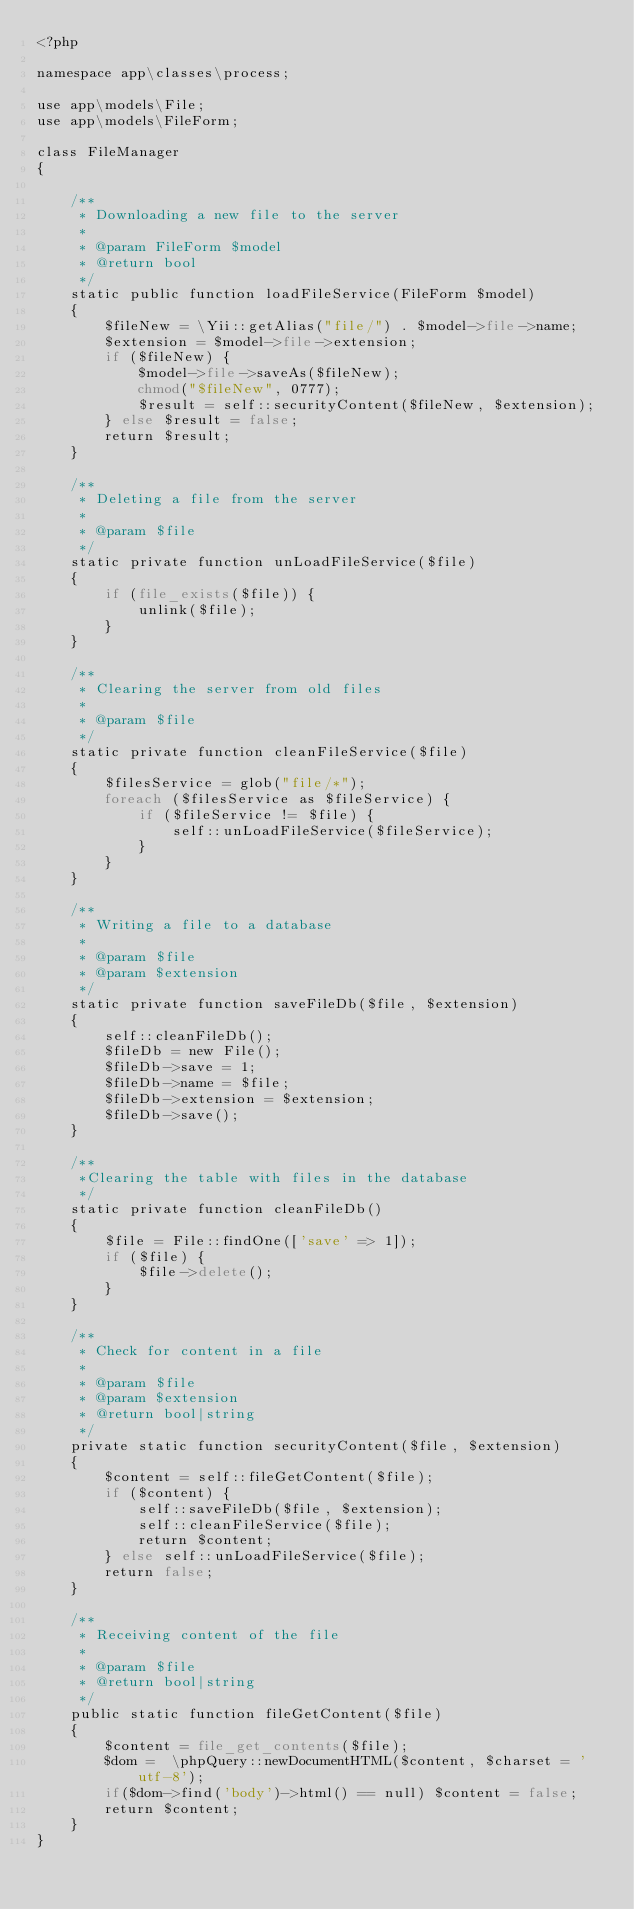Convert code to text. <code><loc_0><loc_0><loc_500><loc_500><_PHP_><?php

namespace app\classes\process;

use app\models\File;
use app\models\FileForm;

class FileManager
{

    /**
     * Downloading a new file to the server
     *
     * @param FileForm $model
     * @return bool
     */
    static public function loadFileService(FileForm $model)
    {
        $fileNew = \Yii::getAlias("file/") . $model->file->name;
        $extension = $model->file->extension;
        if ($fileNew) {
            $model->file->saveAs($fileNew);
            chmod("$fileNew", 0777);
            $result = self::securityContent($fileNew, $extension);
        } else $result = false;
        return $result;
    }

    /**
     * Deleting a file from the server
     *
     * @param $file
     */
    static private function unLoadFileService($file)
    {
        if (file_exists($file)) {
            unlink($file);
        }
    }

    /**
     * Clearing the server from old files
     *
     * @param $file
     */
    static private function cleanFileService($file)
    {
        $filesService = glob("file/*");
        foreach ($filesService as $fileService) {
            if ($fileService != $file) {
                self::unLoadFileService($fileService);
            }
        }
    }

    /**
     * Writing a file to a database
     *
     * @param $file
     * @param $extension
     */
    static private function saveFileDb($file, $extension)
    {
        self::cleanFileDb();
        $fileDb = new File();
        $fileDb->save = 1;
        $fileDb->name = $file;
        $fileDb->extension = $extension;
        $fileDb->save();
    }

    /**
     *Clearing the table with files in the database
     */
    static private function cleanFileDb()
    {
        $file = File::findOne(['save' => 1]);
        if ($file) {
            $file->delete();
        }
    }

    /**
     * Check for content in a file
     *
     * @param $file
     * @param $extension
     * @return bool|string
     */
    private static function securityContent($file, $extension)
    {
        $content = self::fileGetContent($file);
        if ($content) {
            self::saveFileDb($file, $extension);
            self::cleanFileService($file);
            return $content;
        } else self::unLoadFileService($file);
        return false;
    }

    /**
     * Receiving content of the file
     *
     * @param $file
     * @return bool|string
     */
    public static function fileGetContent($file)
    {
        $content = file_get_contents($file);
        $dom =  \phpQuery::newDocumentHTML($content, $charset = 'utf-8');
        if($dom->find('body')->html() == null) $content = false;
        return $content;
    }
}
</code> 